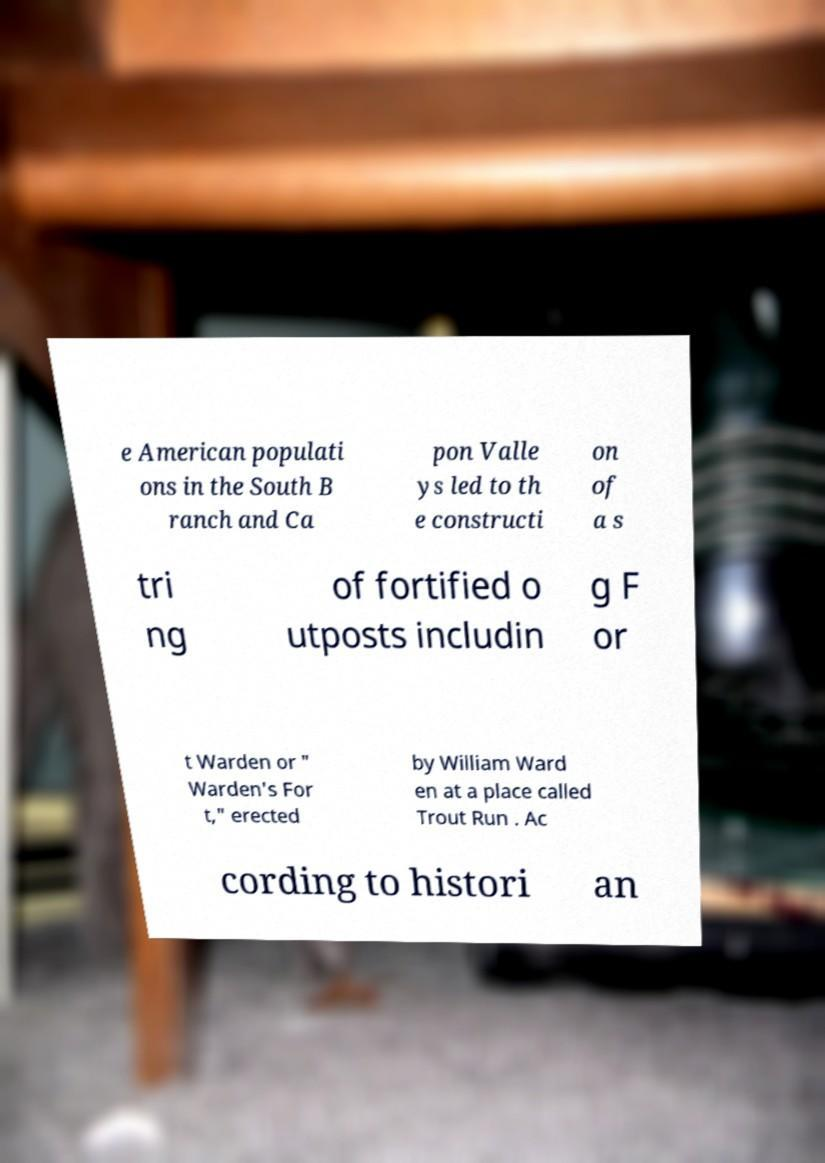Please read and relay the text visible in this image. What does it say? e American populati ons in the South B ranch and Ca pon Valle ys led to th e constructi on of a s tri ng of fortified o utposts includin g F or t Warden or " Warden's For t," erected by William Ward en at a place called Trout Run . Ac cording to histori an 